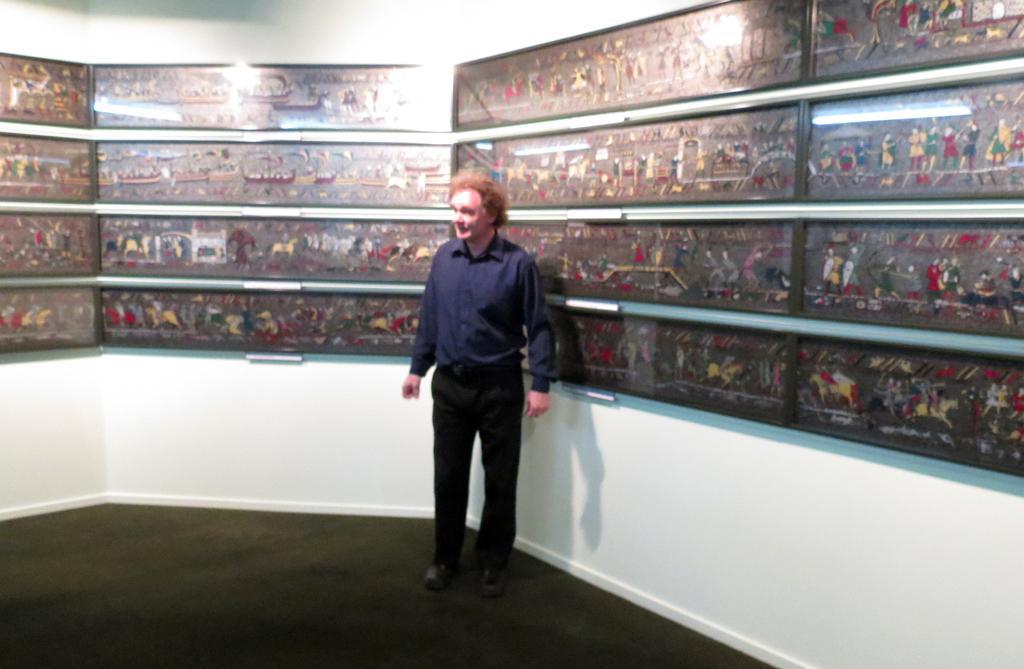Please provide a concise description of this image. On the background of the picture we can see photo frames on a wall. Here we can see a man standing on the floor, near to the frames. 